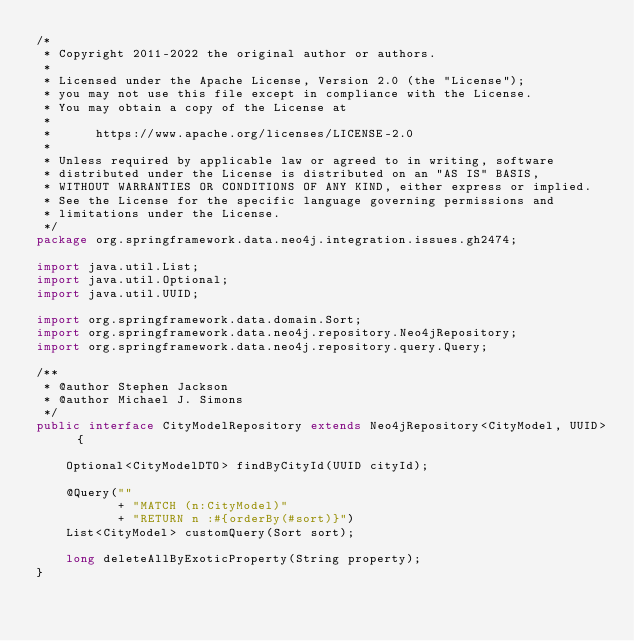Convert code to text. <code><loc_0><loc_0><loc_500><loc_500><_Java_>/*
 * Copyright 2011-2022 the original author or authors.
 *
 * Licensed under the Apache License, Version 2.0 (the "License");
 * you may not use this file except in compliance with the License.
 * You may obtain a copy of the License at
 *
 *      https://www.apache.org/licenses/LICENSE-2.0
 *
 * Unless required by applicable law or agreed to in writing, software
 * distributed under the License is distributed on an "AS IS" BASIS,
 * WITHOUT WARRANTIES OR CONDITIONS OF ANY KIND, either express or implied.
 * See the License for the specific language governing permissions and
 * limitations under the License.
 */
package org.springframework.data.neo4j.integration.issues.gh2474;

import java.util.List;
import java.util.Optional;
import java.util.UUID;

import org.springframework.data.domain.Sort;
import org.springframework.data.neo4j.repository.Neo4jRepository;
import org.springframework.data.neo4j.repository.query.Query;

/**
 * @author Stephen Jackson
 * @author Michael J. Simons
 */
public interface CityModelRepository extends Neo4jRepository<CityModel, UUID> {

	Optional<CityModelDTO> findByCityId(UUID cityId);

	@Query(""
		   + "MATCH (n:CityModel)"
		   + "RETURN n :#{orderBy(#sort)}")
	List<CityModel> customQuery(Sort sort);

	long deleteAllByExoticProperty(String property);
}
</code> 